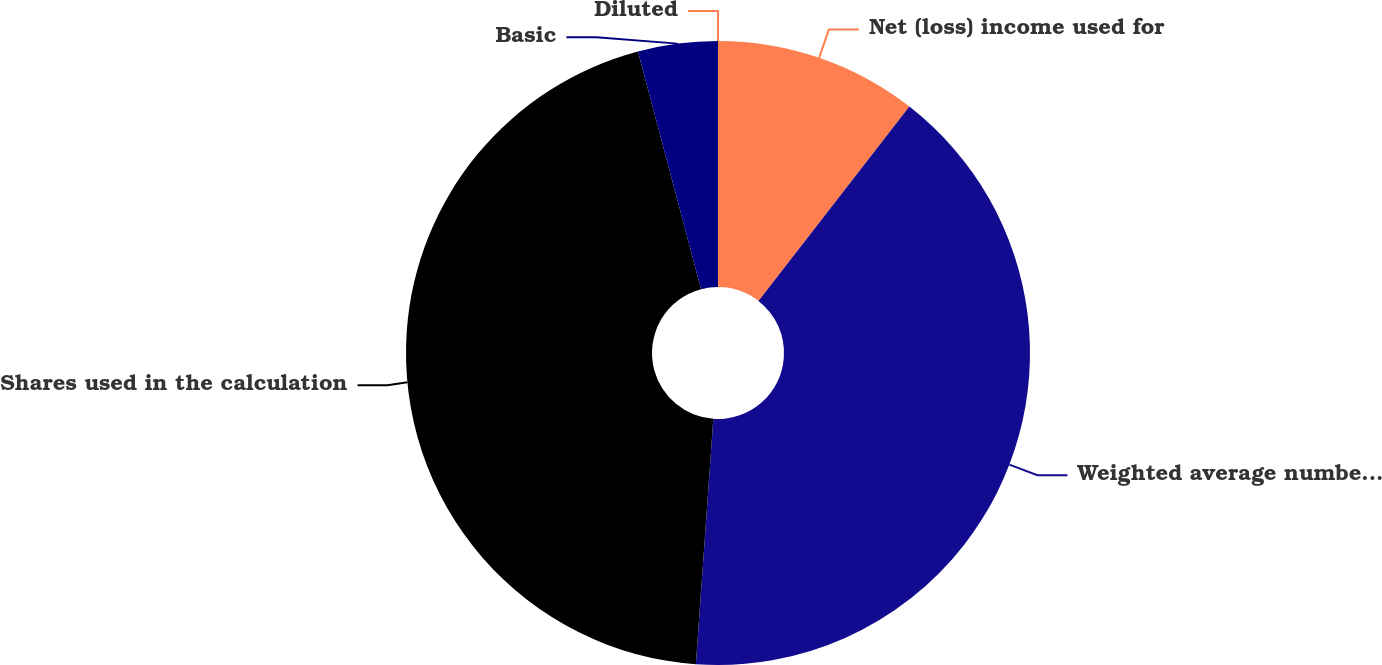<chart> <loc_0><loc_0><loc_500><loc_500><pie_chart><fcel>Net (loss) income used for<fcel>Weighted average number of<fcel>Shares used in the calculation<fcel>Basic<fcel>Diluted<nl><fcel>10.51%<fcel>40.62%<fcel>44.74%<fcel>4.13%<fcel>0.0%<nl></chart> 